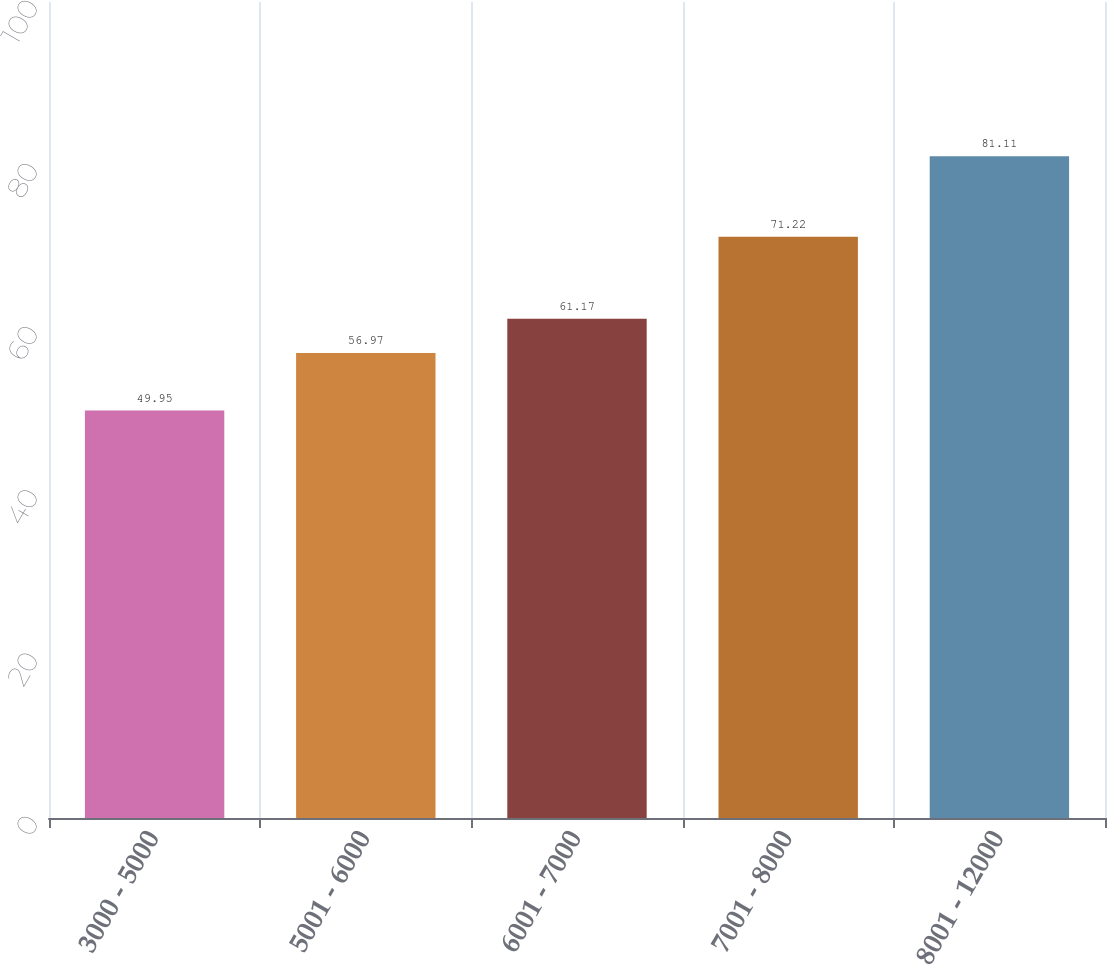Convert chart. <chart><loc_0><loc_0><loc_500><loc_500><bar_chart><fcel>3000 - 5000<fcel>5001 - 6000<fcel>6001 - 7000<fcel>7001 - 8000<fcel>8001 - 12000<nl><fcel>49.95<fcel>56.97<fcel>61.17<fcel>71.22<fcel>81.11<nl></chart> 